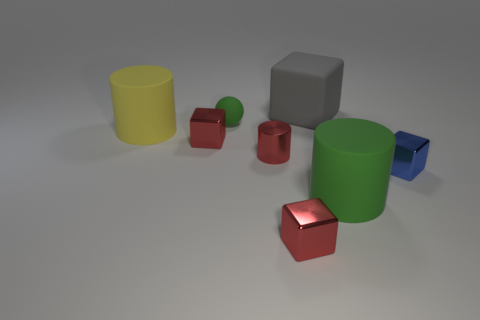Do the block left of the green rubber ball and the big gray block have the same size?
Make the answer very short. No. How many spheres are tiny objects or big things?
Your answer should be very brief. 1. There is a big thing right of the gray rubber object; what is it made of?
Keep it short and to the point. Rubber. Are there fewer small matte things than big yellow balls?
Make the answer very short. No. There is a object that is to the left of the rubber block and in front of the blue object; what size is it?
Offer a terse response. Small. How big is the thing that is in front of the big green matte object left of the metallic object right of the gray thing?
Provide a succinct answer. Small. How many other things are the same color as the rubber block?
Offer a terse response. 0. Is the color of the large cylinder to the right of the large yellow rubber cylinder the same as the tiny rubber ball?
Make the answer very short. Yes. How many objects are either yellow objects or tiny red metallic cylinders?
Offer a very short reply. 2. What color is the cylinder to the left of the sphere?
Ensure brevity in your answer.  Yellow. 